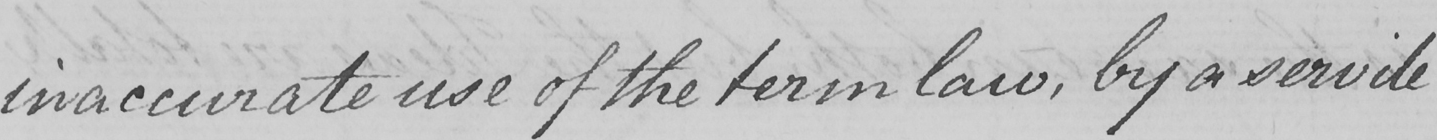What text is written in this handwritten line? inaccurate use of the term law , by a servile 